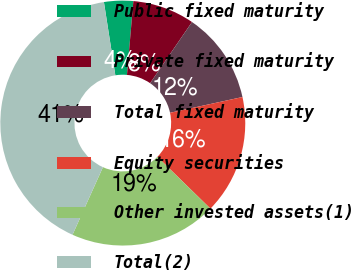Convert chart to OTSL. <chart><loc_0><loc_0><loc_500><loc_500><pie_chart><fcel>Public fixed maturity<fcel>Private fixed maturity<fcel>Total fixed maturity<fcel>Equity securities<fcel>Other invested assets(1)<fcel>Total(2)<nl><fcel>3.84%<fcel>8.18%<fcel>12.03%<fcel>15.72%<fcel>19.42%<fcel>40.8%<nl></chart> 